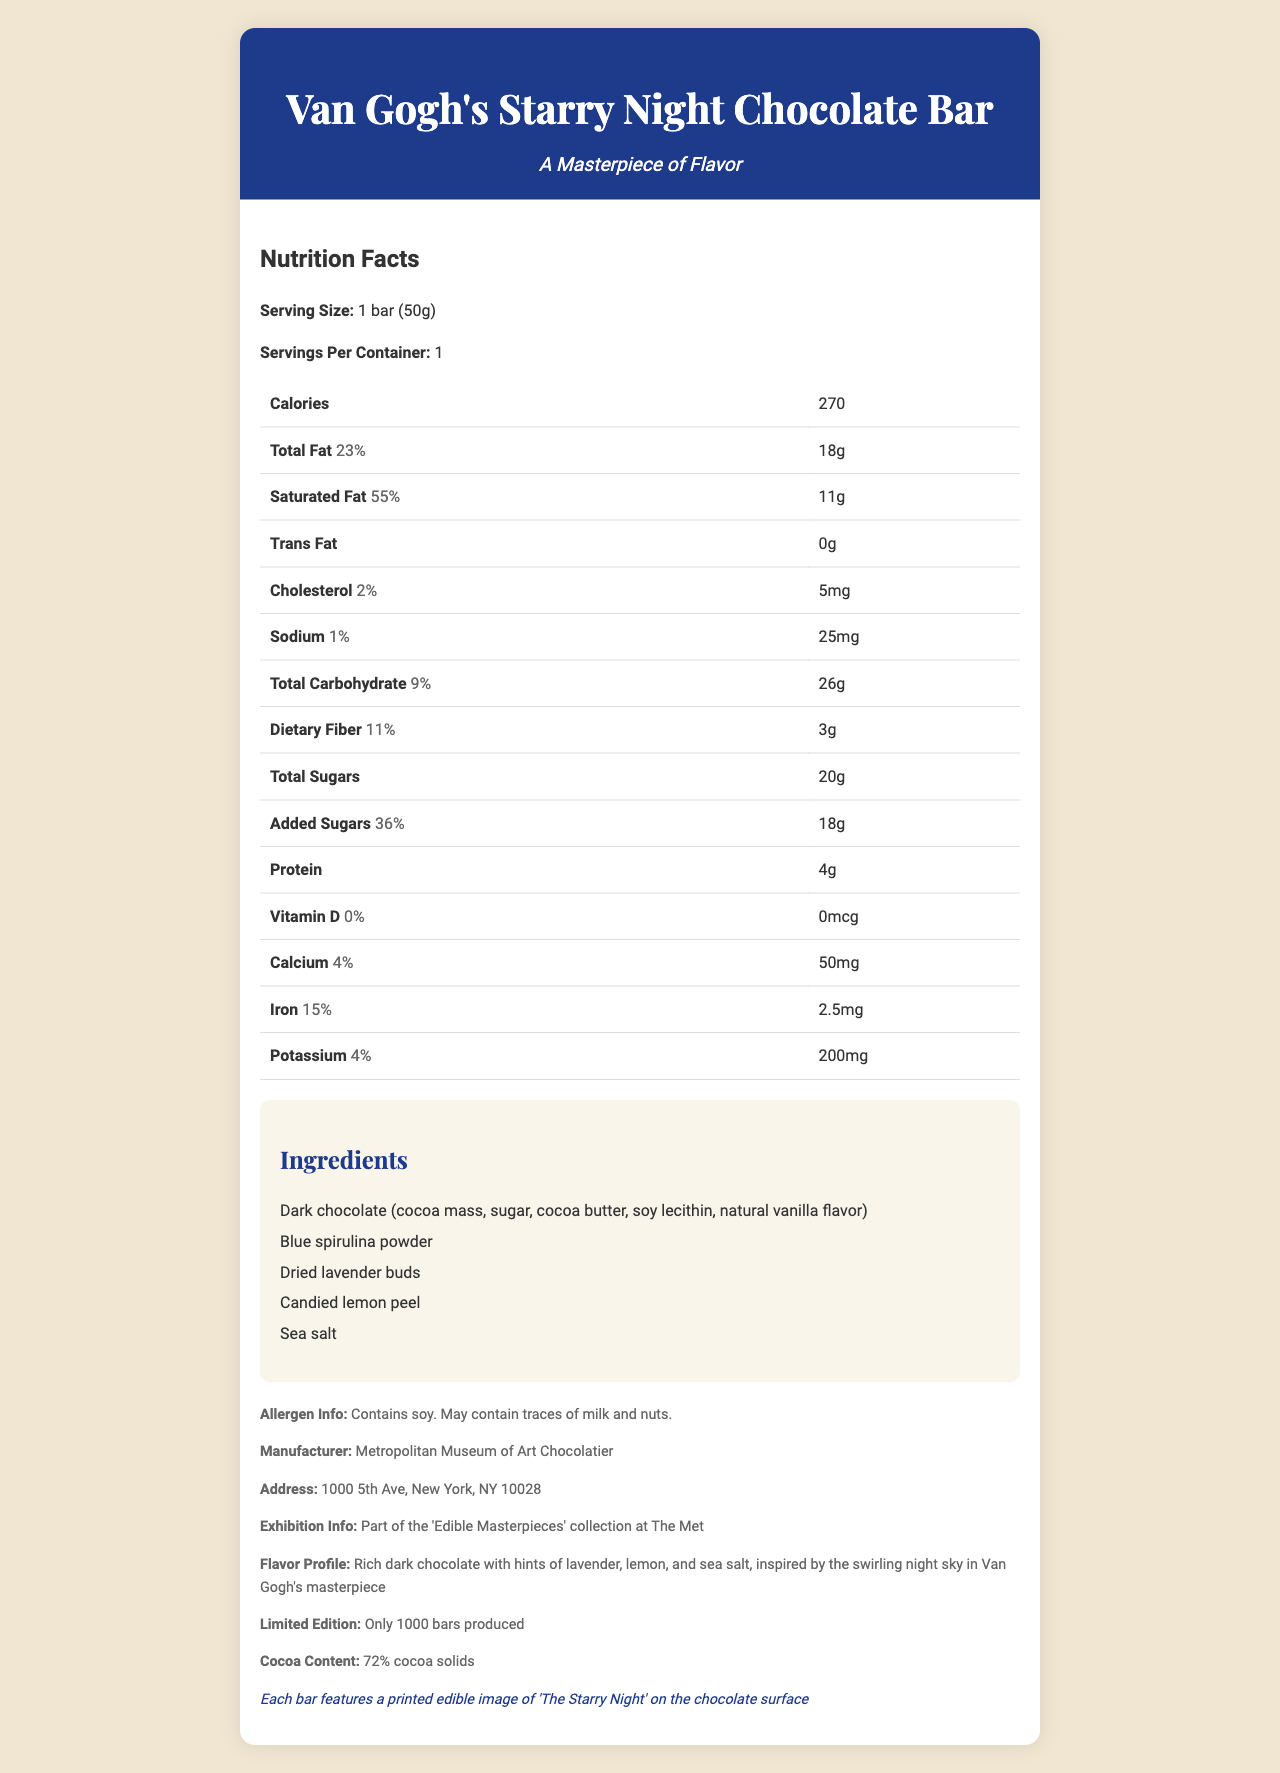what is the serving size of the Van Gogh's Starry Night Chocolate Bar? The document clearly states the serving size as "1 bar (50g)".
Answer: 1 bar (50g) how many calories are in one serving of the chocolate bar? The calories per serving are listed under the Nutrition Facts section as 270.
Answer: 270 what percentage of your daily value of total fat does one serving provide? The Total Fat's daily value is listed as 23% in the Nutrition Facts table.
Answer: 23% what ingredients give the chocolate bar its unique flavor? These ingredients are listed in the Ingredients section and contribute to the unique flavor profile mentioned.
Answer: Blue spirulina powder, dried lavender buds, candied lemon peel, sea salt what is the cocoa content of this limited edition chocolate bar? The document lists the cocoa content under the additional info section as "72% cocoa solids".
Answer: 72% cocoa solids which allergen is definitely present in the chocolate bar? A. Nuts B. Milk C. Soy The Allergen Info explicitly states "Contains soy".
Answer: C. Soy how many grams of protein are in the chocolate bar? A. 2g B. 4g C. 6g D. 8g The protein amount is listed as 4g in the Nutrition Facts table.
Answer: B. 4g how much added sugar is in the chocolate bar? The document lists the added sugars as 18g in the Nutrition Facts table.
Answer: 18g is the Van Gogh's Starry Night Chocolate Bar part of an exhibition collection? The document mentions that it is part of the 'Edible Masterpieces' collection at The Met.
Answer: Yes will this chocolate bar meet the daily requirement for Vitamin D? The Vitamin D daily value is listed as 0%, indicating it does not contribute to the daily requirement.
Answer: No describe the main idea of the document The document offers a comprehensive overview of the chocolate bar including its nutritional facts, unique ingredients, artistic connections, and its place in the 'Edible Masterpieces' collection.
Answer: The document provides detailed nutritional information about the Van Gogh's Starry Night Chocolate Bar, a limited edition artisanal chocolate bar inspired by "The Starry Night" painting. It includes details about ingredients, allergen info, nutritional content, and its participation in an exhibition collection at The Met. how many bars are produced for this limited edition? The limited edition section states that only 1000 bars were produced.
Answer: 1000 bars who is the manufacturer of the chocolate bar? The manufacturer is mentioned in the additional info section as the Metropolitan Museum of Art Chocolatier.
Answer: Metropolitan Museum of Art Chocolatier does the chocolate bar have an edible image of 'The Starry Night' on its surface? A. Yes B. No C. It varies The artistic note mentions that each bar features a printed edible image of 'The Starry Night' on the chocolate surface.
Answer: A. Yes what is the address of the manufacturer? The address of the Metropolitan Museum of Art Chocolatier is provided in the additional info section.
Answer: 1000 5th Ave, New York, NY 10028 is there any information about the recommended consumption time for the chocolate bar? The document does not provide any information regarding the recommended consumption time.
Answer: Not enough information 